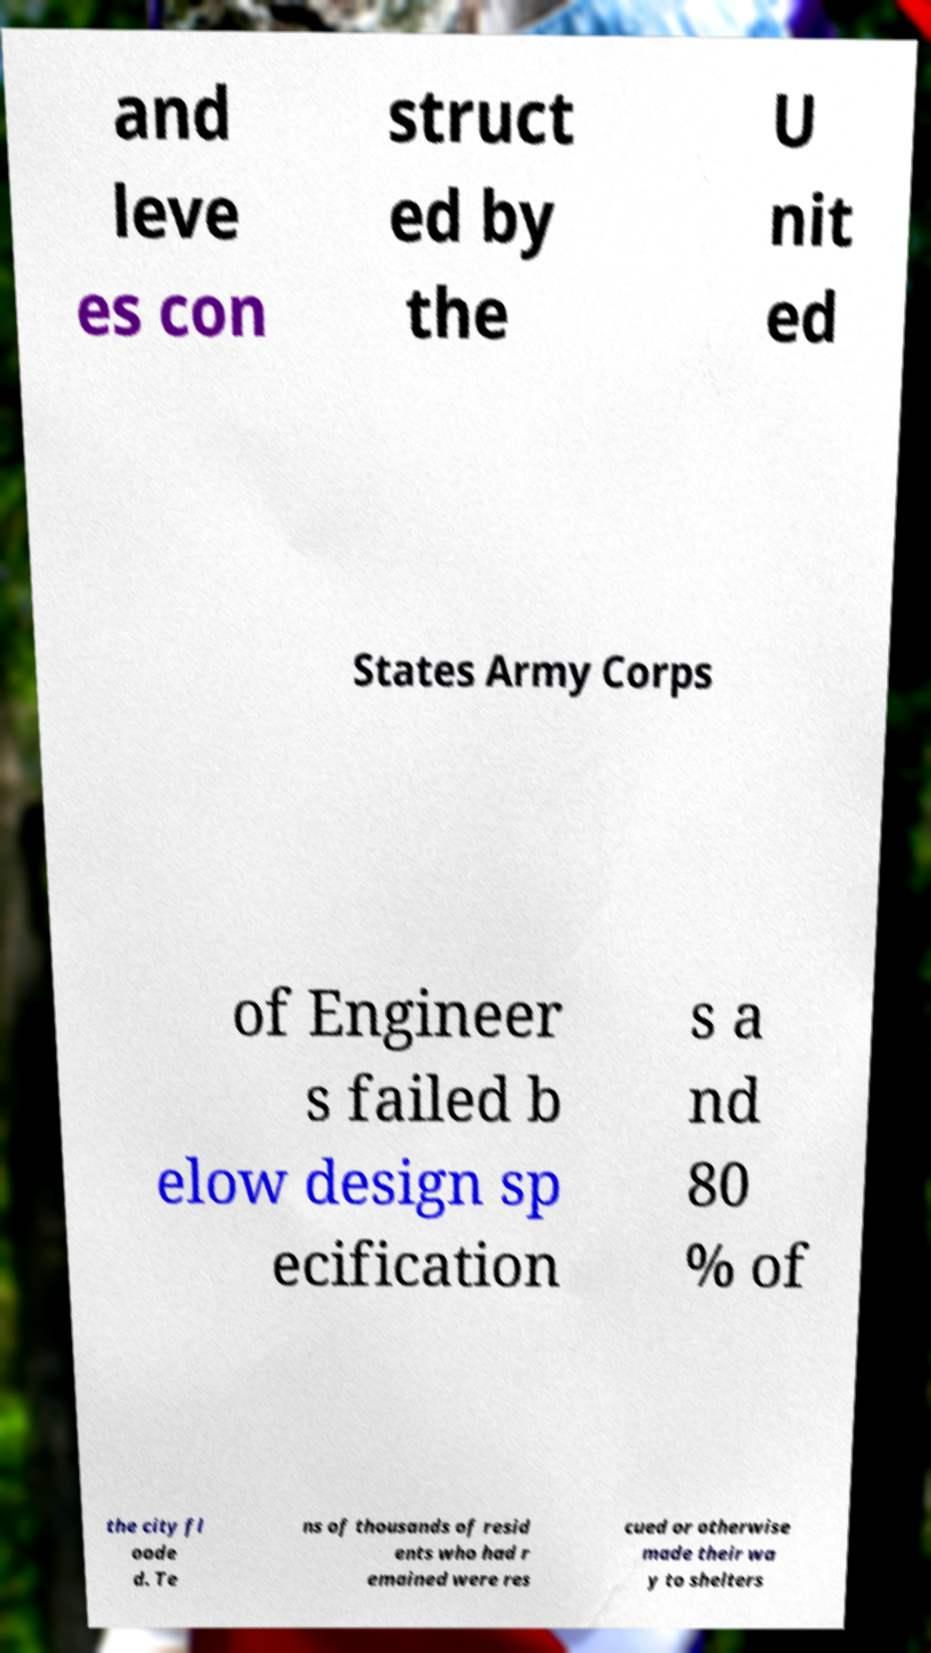There's text embedded in this image that I need extracted. Can you transcribe it verbatim? and leve es con struct ed by the U nit ed States Army Corps of Engineer s failed b elow design sp ecification s a nd 80 % of the city fl oode d. Te ns of thousands of resid ents who had r emained were res cued or otherwise made their wa y to shelters 